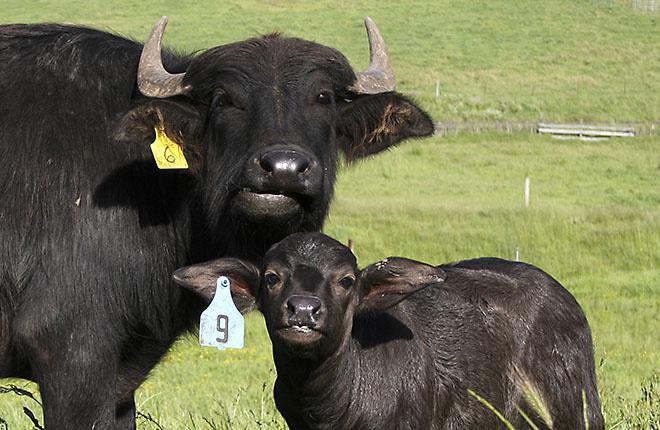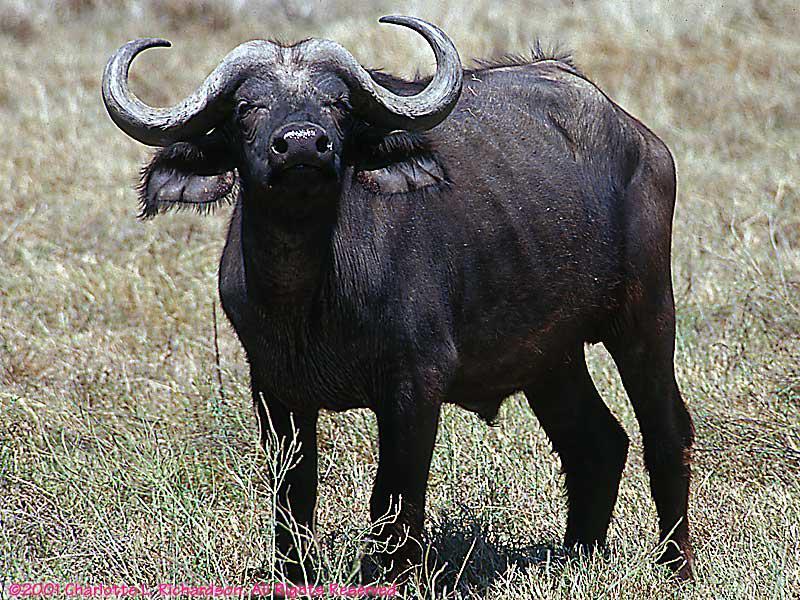The first image is the image on the left, the second image is the image on the right. Examine the images to the left and right. Is the description "All water buffalo are standing, and one image contains multiple water buffalo." accurate? Answer yes or no. Yes. The first image is the image on the left, the second image is the image on the right. For the images displayed, is the sentence "The cow in the image on the left is lying down." factually correct? Answer yes or no. No. 